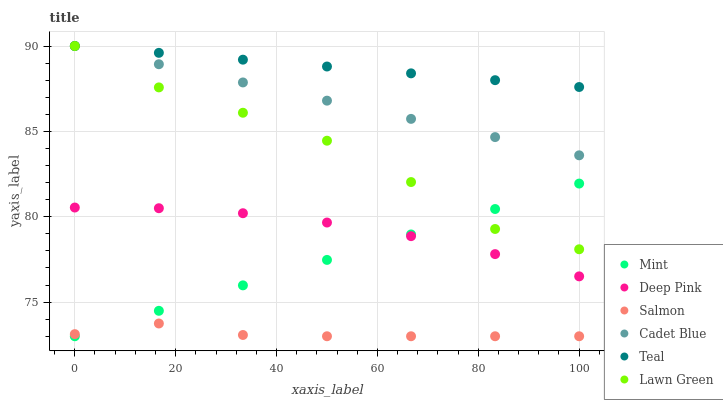Does Salmon have the minimum area under the curve?
Answer yes or no. Yes. Does Teal have the maximum area under the curve?
Answer yes or no. Yes. Does Cadet Blue have the minimum area under the curve?
Answer yes or no. No. Does Cadet Blue have the maximum area under the curve?
Answer yes or no. No. Is Cadet Blue the smoothest?
Answer yes or no. Yes. Is Lawn Green the roughest?
Answer yes or no. Yes. Is Salmon the smoothest?
Answer yes or no. No. Is Salmon the roughest?
Answer yes or no. No. Does Salmon have the lowest value?
Answer yes or no. Yes. Does Cadet Blue have the lowest value?
Answer yes or no. No. Does Teal have the highest value?
Answer yes or no. Yes. Does Salmon have the highest value?
Answer yes or no. No. Is Salmon less than Cadet Blue?
Answer yes or no. Yes. Is Lawn Green greater than Salmon?
Answer yes or no. Yes. Does Teal intersect Cadet Blue?
Answer yes or no. Yes. Is Teal less than Cadet Blue?
Answer yes or no. No. Is Teal greater than Cadet Blue?
Answer yes or no. No. Does Salmon intersect Cadet Blue?
Answer yes or no. No. 